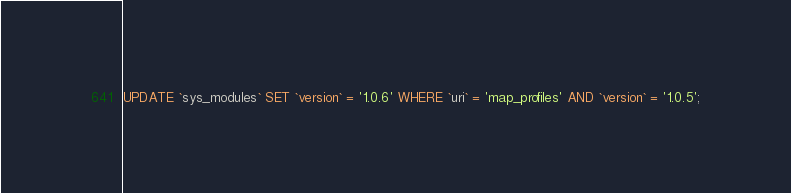<code> <loc_0><loc_0><loc_500><loc_500><_SQL_>

UPDATE `sys_modules` SET `version` = '1.0.6' WHERE `uri` = 'map_profiles' AND `version` = '1.0.5';

</code> 